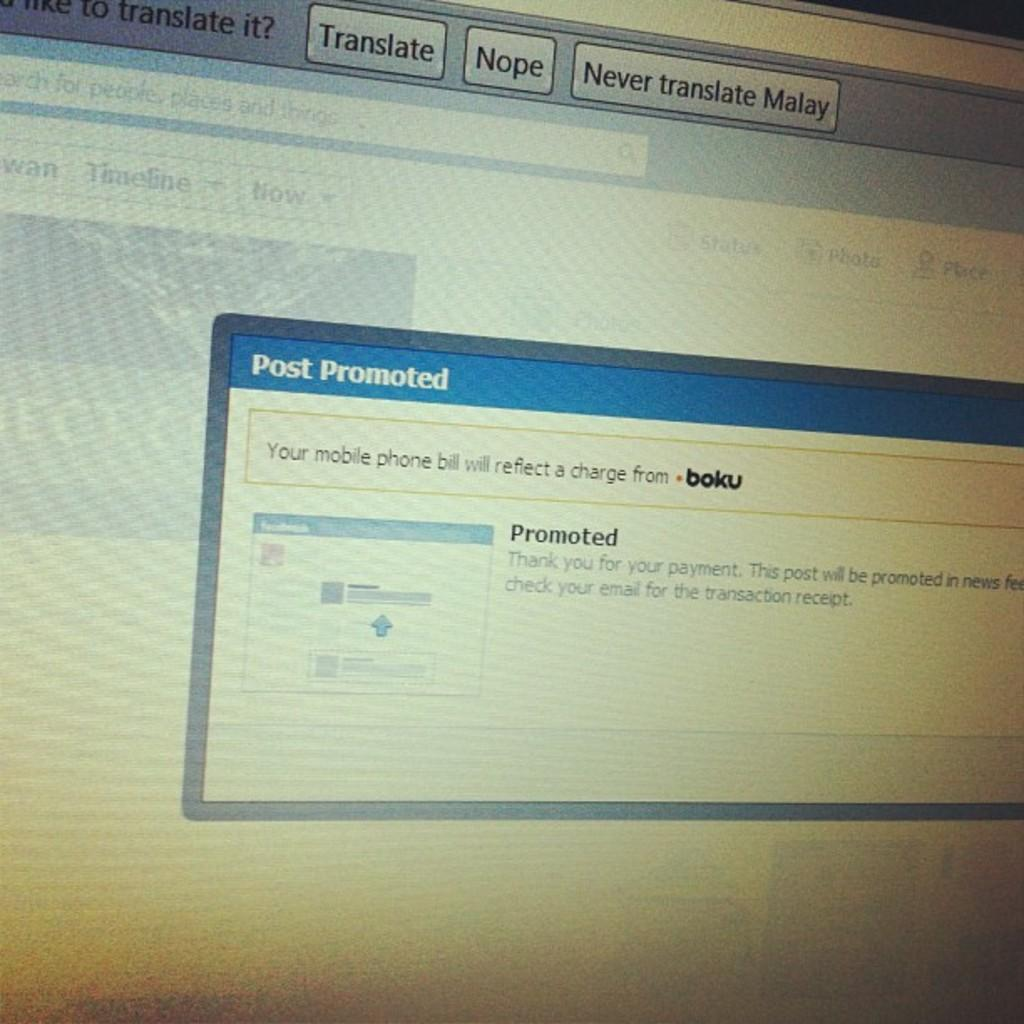<image>
Provide a brief description of the given image. A pop up screen on a computer is titled Post Promoted. 